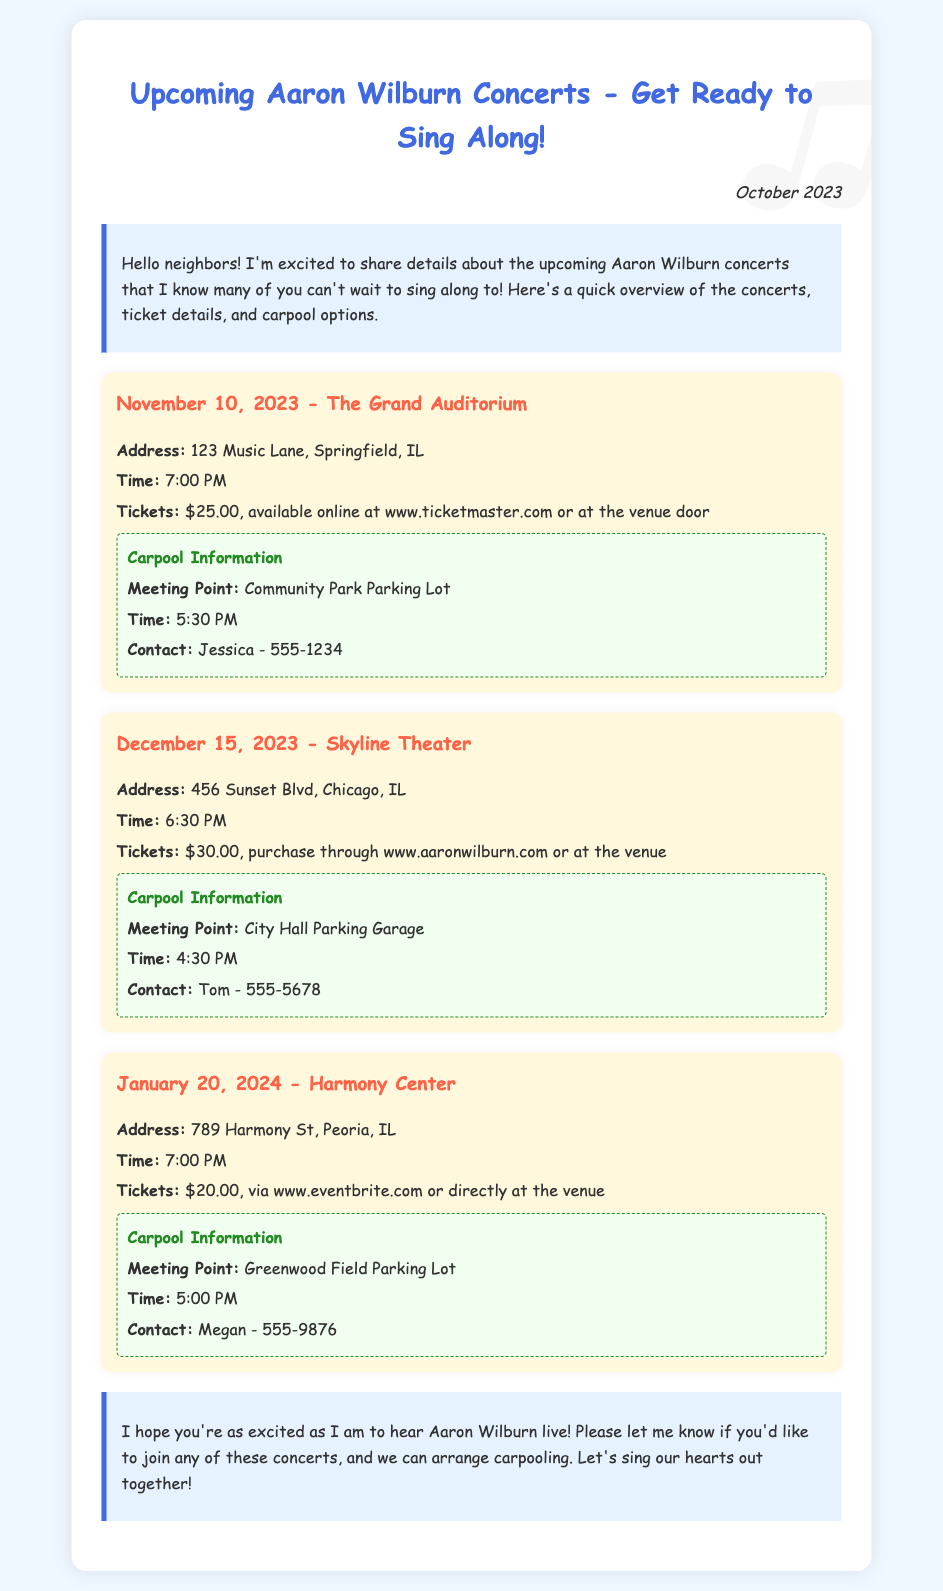What is the date of the concert at The Grand Auditorium? The date of the concert at The Grand Auditorium is mentioned as November 10, 2023.
Answer: November 10, 2023 What is the ticket price for the concert at Skyline Theater? The ticket price for the concert at Skyline Theater is provided as $30.00.
Answer: $30.00 Where is the concert on January 20, 2024, being held? The concert on January 20, 2024, is taking place at Harmony Center, as mentioned in the address.
Answer: Harmony Center What time do we need to meet for the carpool to the concert in Springfield? The carpool time for the concert in Springfield is 5:30 PM, as indicated in the carpool information.
Answer: 5:30 PM Who should I contact for carpooling to the concert in Chicago? The document specifies to contact Tom for carpooling to the concert in Chicago.
Answer: Tom How much earlier must I arrive for the concert at Harmony Center? To reach the concert at Harmony Center on time, you should arrive 2 hours before the show starts, based on the carpool arrangement.
Answer: 2 hours Which concert has the lowest ticket price? The document shows that the Harmony Center concert has the lowest ticket price of $20.00.
Answer: $20.00 What is the contact number for the carpool to the concert in Peoria? The contact number for the carpool to the concert in Peoria is listed as 555-9876.
Answer: 555-9876 Which concert has a meeting point at City Hall Parking Garage? The concert at Skyline Theater has a meeting point at City Hall Parking Garage, mentioned in the carpool information.
Answer: Skyline Theater 